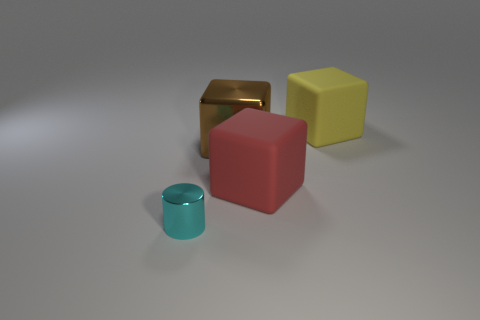Subtract all red rubber cubes. How many cubes are left? 2 Add 1 big rubber cubes. How many objects exist? 5 Subtract 1 blocks. How many blocks are left? 2 Subtract all cylinders. How many objects are left? 3 Subtract 0 red cylinders. How many objects are left? 4 Subtract all brown cylinders. Subtract all blue spheres. How many cylinders are left? 1 Subtract all small blue blocks. Subtract all large matte things. How many objects are left? 2 Add 4 large brown things. How many large brown things are left? 5 Add 1 large metallic objects. How many large metallic objects exist? 2 